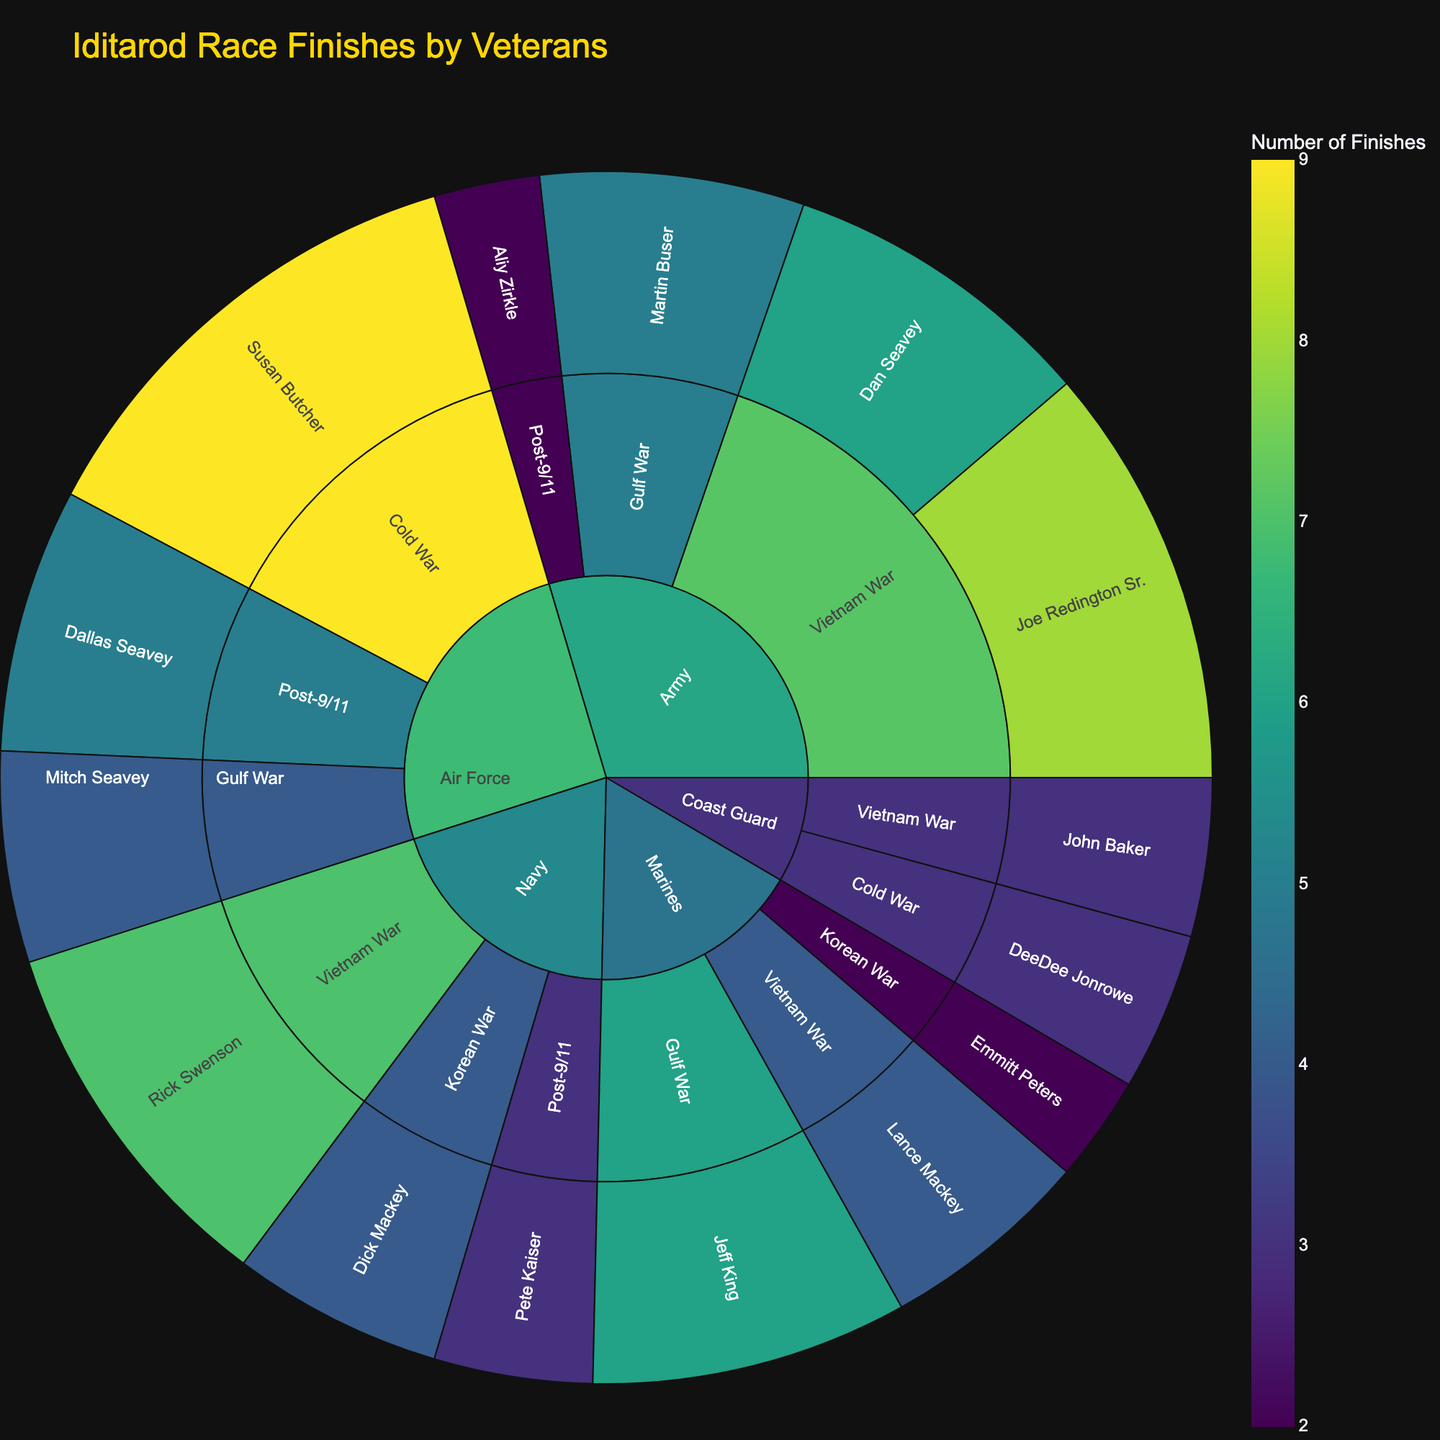What's the title of the sunburst plot? The title of the sunburst plot is typically found at the top center. By observing, you can see the title that describes the content of the figure.
Answer: Iditarod Race Finishes by Veterans Which military branch has the highest number of veterans represented? Look at the outermost ring to identify the different branches and count the number of unique veterans each branch has. The branch with the greatest count is the answer.
Answer: Army How many finishes did Susan Butcher from the Air Force have? Locate the Air Force section in the sunburst plot, then find Susan Butcher within that section. The number of finishes will be displayed in her segment.
Answer: 9 Which era has the fewest number of finishes for the Navy? Navigate to the Navy category and compare the different eras. Sum up the finishes for each era and identify which has the smallest sum.
Answer: Korean War Who are the veterans from the Gulf War in the Marines branch and how many total finishes do they have combined? Find the Marines branch and then look for the Gulf War segment. Identify the veterans' names and sum their finishes.
Answer: Jeff King, 6 finishes Compare the number of finishes between Rick Swenson from the Navy and Lance Mackey from the Marines. Who has more finishes and by how many? Locate Rick Swenson in the Navy segment and note his finishes, then find Lance Mackey in the Marines segment and note his finishes. Subtract Mackey's finishes from Swenson's to find the difference.
Answer: Rick Swenson, 3 more finishes Which military branch has veterans participating in all four listed eras? Check each military branch to see if all four eras (Korean War, Vietnam War, Gulf War, Post-9/11) are present in the sunburst plot.
Answer: Army What is the average number of finishes for veterans in the Post-9/11 era? Identify all the veterans listed under the Post-9/11 era across branches, sum their finishes, and divide by the number of veterans.
Answer: 3.3 What's the total number of finishes for all veterans from the Coast Guard branch combined? Locate the Coast Guard section and sum the finishes of all the veterans listed within that section.
Answer: 6 Which branch has more finishes in the Vietnam War era, Army or Marines? Look at the finishes for both the Army and Marines in the Vietnam War era, sum up each branch's finishes, and compare.
Answer: Army 